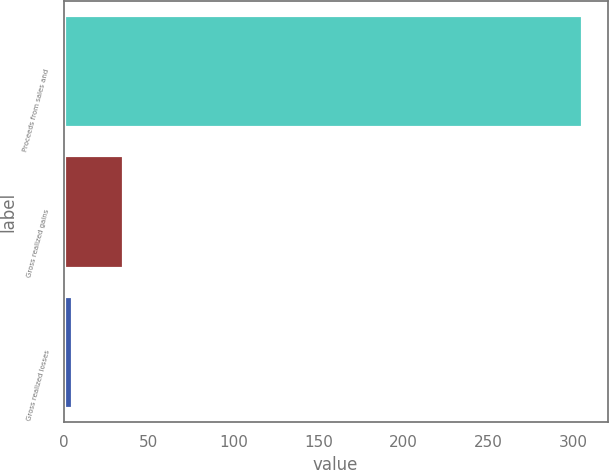<chart> <loc_0><loc_0><loc_500><loc_500><bar_chart><fcel>Proceeds from sales and<fcel>Gross realized gains<fcel>Gross realized losses<nl><fcel>305<fcel>35<fcel>5<nl></chart> 